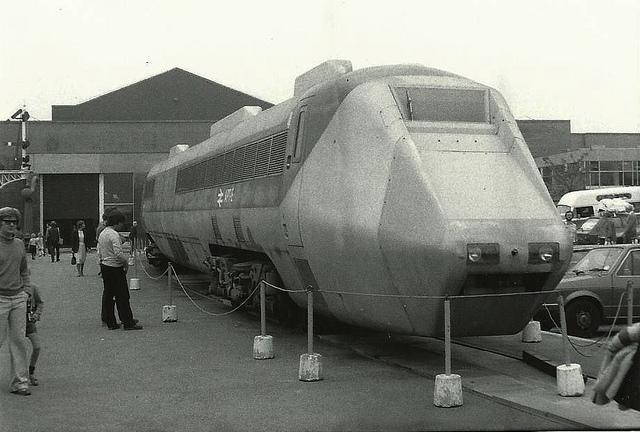Where is this train located?
From the following set of four choices, select the accurate answer to respond to the question.
Options: Museum, bridge, country, tunnel. Museum. 